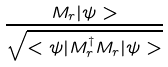<formula> <loc_0><loc_0><loc_500><loc_500>\frac { M _ { r } | \psi > } { \sqrt { < \psi | M _ { r } ^ { \dagger } M _ { r } | \psi > } }</formula> 